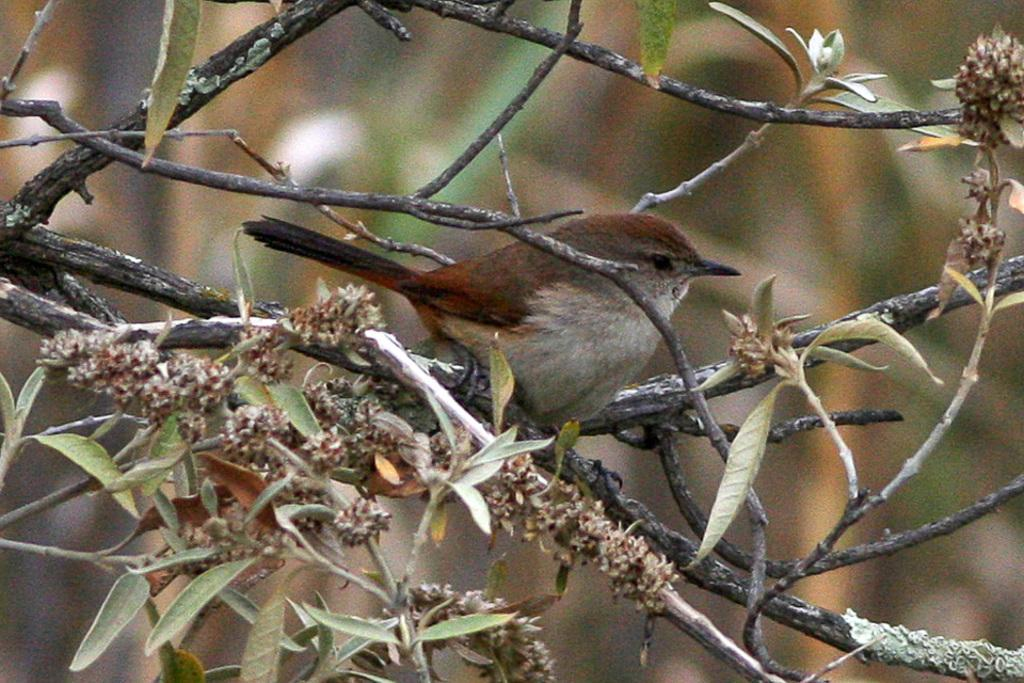What type of animal can be seen in the image? There is a bird in the image. Where is the bird located? The bird is sitting on a branch of a tree. What can be found on the branch where the bird is sitting? There are leaves on the branch. What type of yarn is the bird using to knit a sweater in the image? There is no yarn or sweater present in the image; it features a bird sitting on a branch of a tree with leaves. 